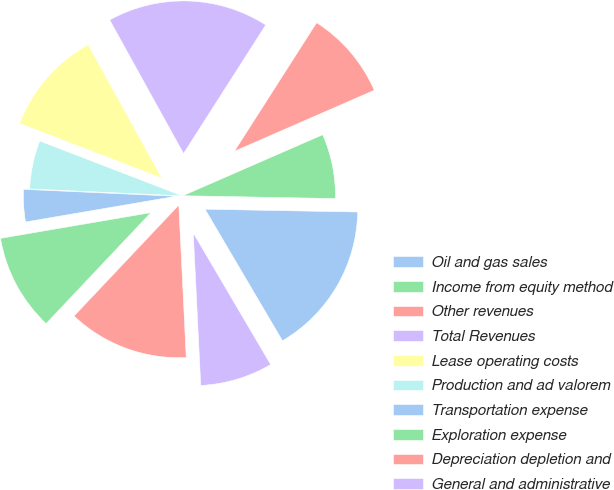Convert chart. <chart><loc_0><loc_0><loc_500><loc_500><pie_chart><fcel>Oil and gas sales<fcel>Income from equity method<fcel>Other revenues<fcel>Total Revenues<fcel>Lease operating costs<fcel>Production and ad valorem<fcel>Transportation expense<fcel>Exploration expense<fcel>Depreciation depletion and<fcel>General and administrative<nl><fcel>16.24%<fcel>6.84%<fcel>9.4%<fcel>17.09%<fcel>11.11%<fcel>5.13%<fcel>3.42%<fcel>10.26%<fcel>12.82%<fcel>7.69%<nl></chart> 